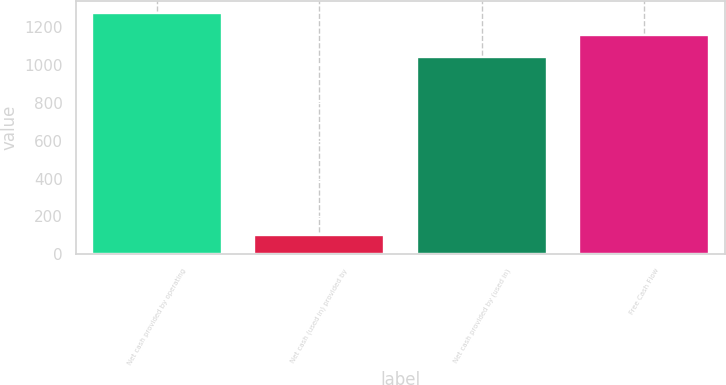Convert chart. <chart><loc_0><loc_0><loc_500><loc_500><bar_chart><fcel>Net cash provided by operating<fcel>Net cash (used in) provided by<fcel>Net cash provided by (used in)<fcel>Free Cash Flow<nl><fcel>1274.34<fcel>102<fcel>1042.9<fcel>1158.62<nl></chart> 